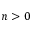Convert formula to latex. <formula><loc_0><loc_0><loc_500><loc_500>n > 0</formula> 